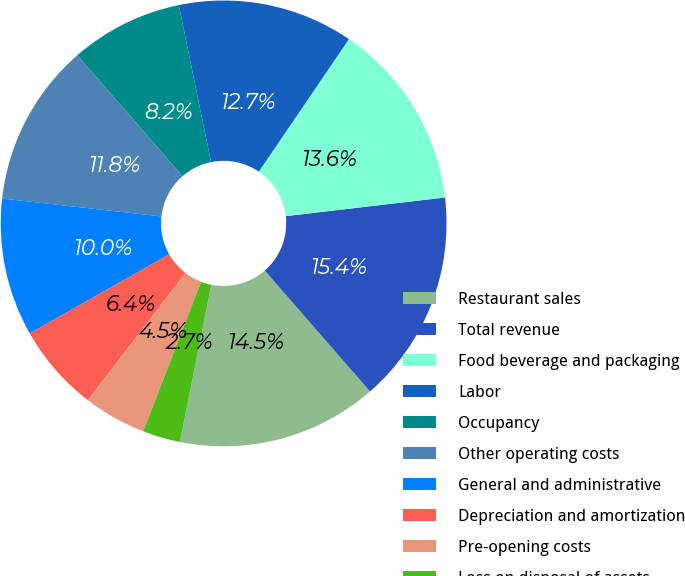<chart> <loc_0><loc_0><loc_500><loc_500><pie_chart><fcel>Restaurant sales<fcel>Total revenue<fcel>Food beverage and packaging<fcel>Labor<fcel>Occupancy<fcel>Other operating costs<fcel>General and administrative<fcel>Depreciation and amortization<fcel>Pre-opening costs<fcel>Loss on disposal of assets<nl><fcel>14.55%<fcel>15.45%<fcel>13.64%<fcel>12.73%<fcel>8.18%<fcel>11.82%<fcel>10.0%<fcel>6.36%<fcel>4.55%<fcel>2.73%<nl></chart> 